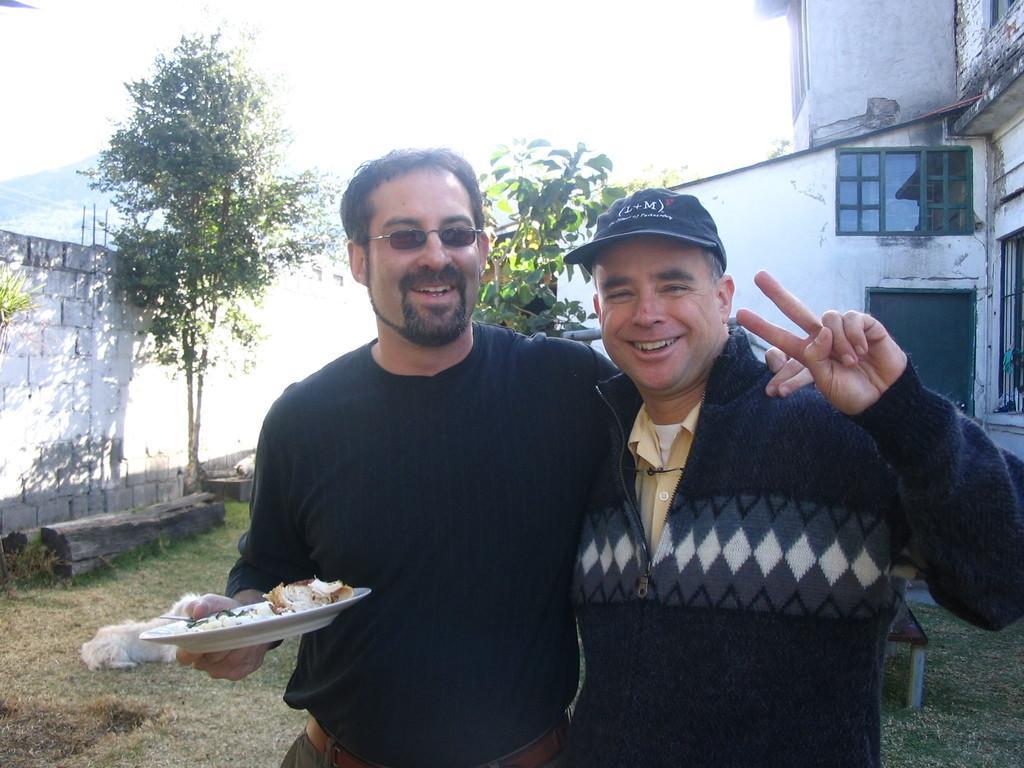Please provide a concise description of this image. In this image we can see two men. Man on the right side is wearing a cap. Man on the left side is wearing specs and holding a plate with food item. In the back there is an animal on the ground. Also there are trees. On the left side there is a wall. On the right side there is a building with windows. In the background it is white. 